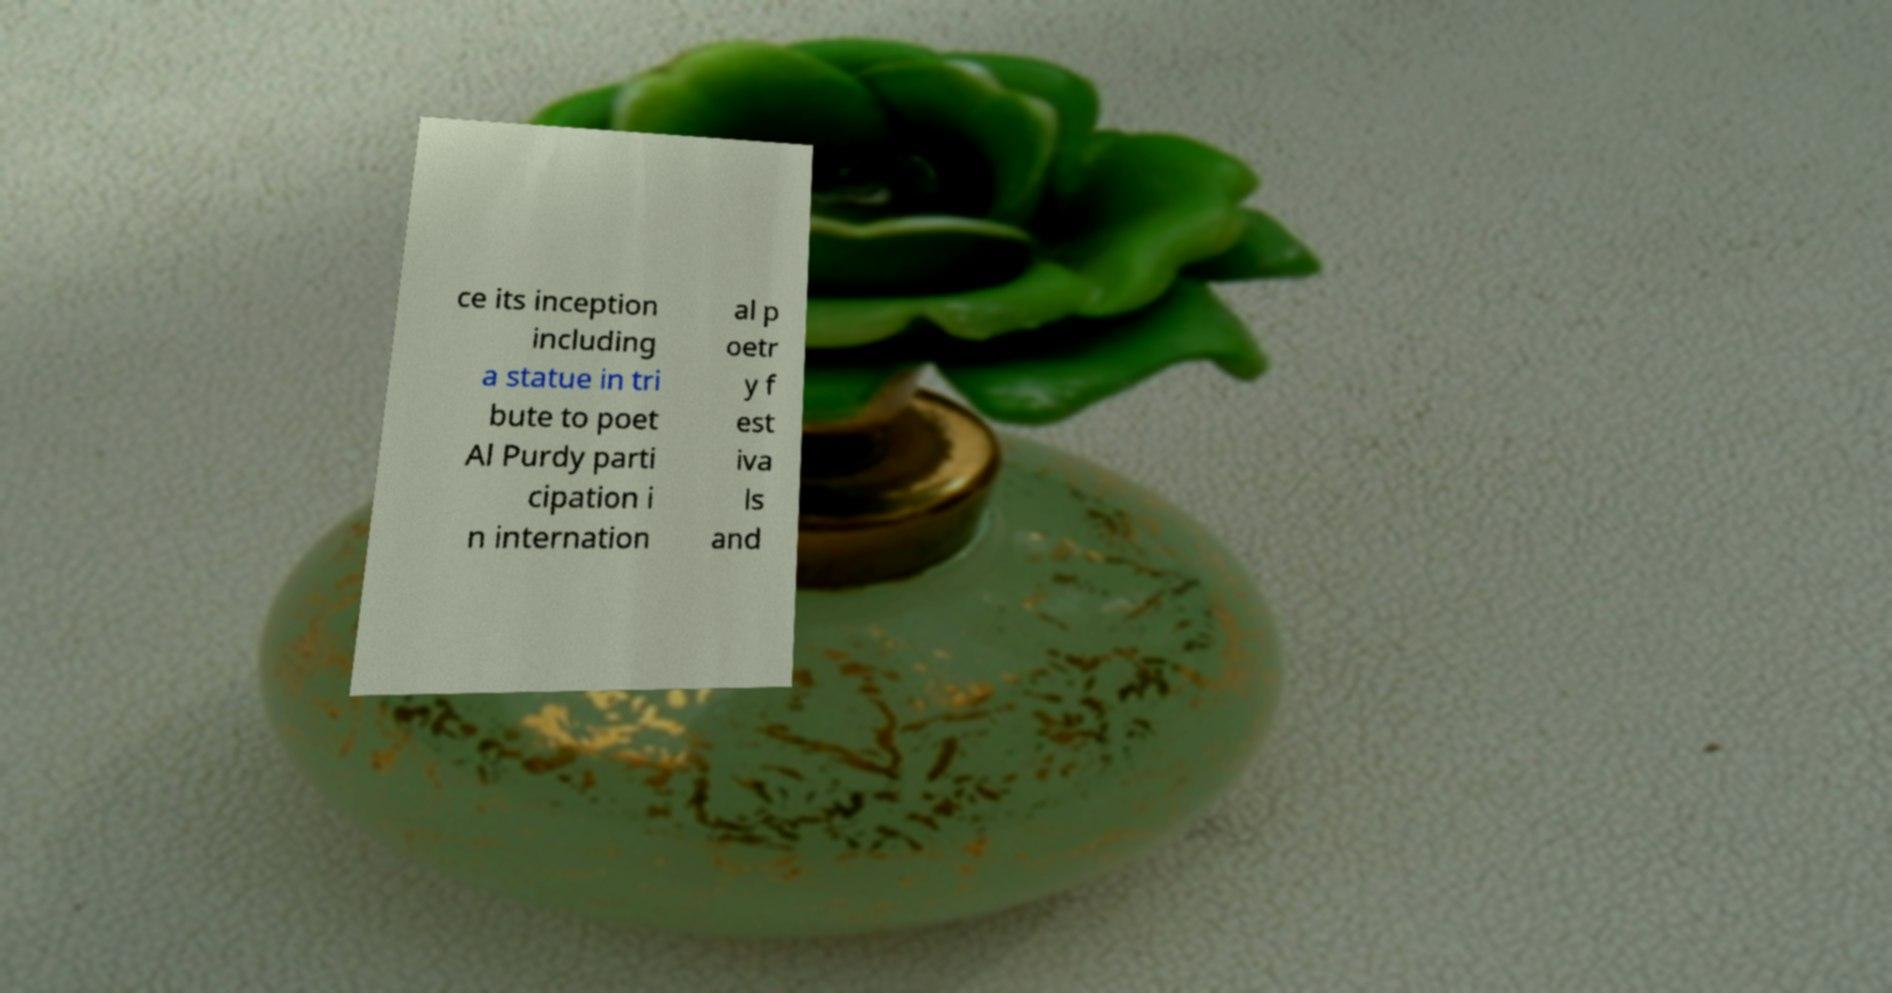Can you read and provide the text displayed in the image?This photo seems to have some interesting text. Can you extract and type it out for me? ce its inception including a statue in tri bute to poet Al Purdy parti cipation i n internation al p oetr y f est iva ls and 